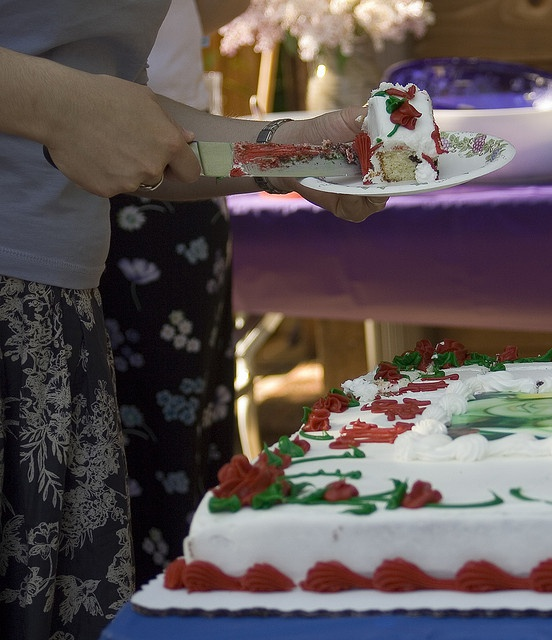Describe the objects in this image and their specific colors. I can see people in black and gray tones, cake in black, darkgray, maroon, and lightgray tones, dining table in black, brown, and navy tones, bowl in black, darkgray, navy, and blue tones, and dining table in black, darkblue, and navy tones in this image. 